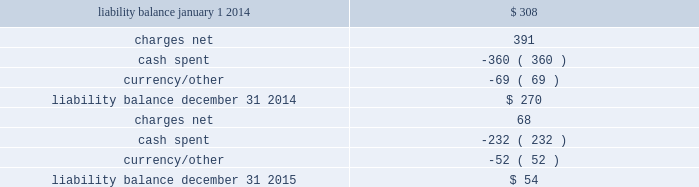Movement in exit cost liabilities the movement in exit cost liabilities for pmi was as follows : ( in millions ) .
Cash payments related to exit costs at pmi were $ 232 million , $ 360 million and $ 21 million for the years ended december 31 , 2015 , 2014 and 2013 , respectively .
Future cash payments for exit costs incurred to date are expected to be approximately $ 54 million , and will be substantially paid by the end of 2017 .
The pre-tax asset impairment and exit costs shown above are primarily a result of the following : the netherlands on april 4 , 2014 , pmi announced the initiation by its affiliate , philip morris holland b.v .
( 201cpmh 201d ) , of consultations with employee representatives on a proposal to discontinue cigarette production at its factory located in bergen op zoom , the netherlands .
Pmh reached an agreement with the trade unions and their members on a social plan and ceased cigarette production on september 1 , 2014 .
During 2014 , total pre-tax asset impairment and exit costs of $ 489 million were recorded for this program in the european union segment .
This amount includes employee separation costs of $ 343 million , asset impairment costs of $ 139 million and other separation costs of $ 7 million .
Separation program charges pmi recorded other pre-tax separation program charges of $ 68 million , $ 41 million and $ 51 million for the years ended december 31 , 2015 , 2014 and 2013 , respectively .
The 2015 other pre-tax separation program charges primarily related to severance costs for the organizational restructuring in the european union segment .
The 2014 other pre-tax separation program charges primarily related to severance costs for factory closures in australia and canada and the restructuring of the u.s .
Leaf purchasing model .
The 2013 pre-tax separation program charges primarily related to the restructuring of global and regional functions based in switzerland and australia .
Contract termination charges during 2013 , pmi recorded exit costs of $ 258 million related to the termination of distribution agreements in eastern europe , middle east & africa ( due to a new business model in egypt ) and asia .
Asset impairment charges during 2014 , pmi recorded other pre-tax asset impairment charges of $ 5 million related to a factory closure in canada. .
What is the change in liability balance during 2015? 
Computations: (54 - 270)
Answer: -216.0. 